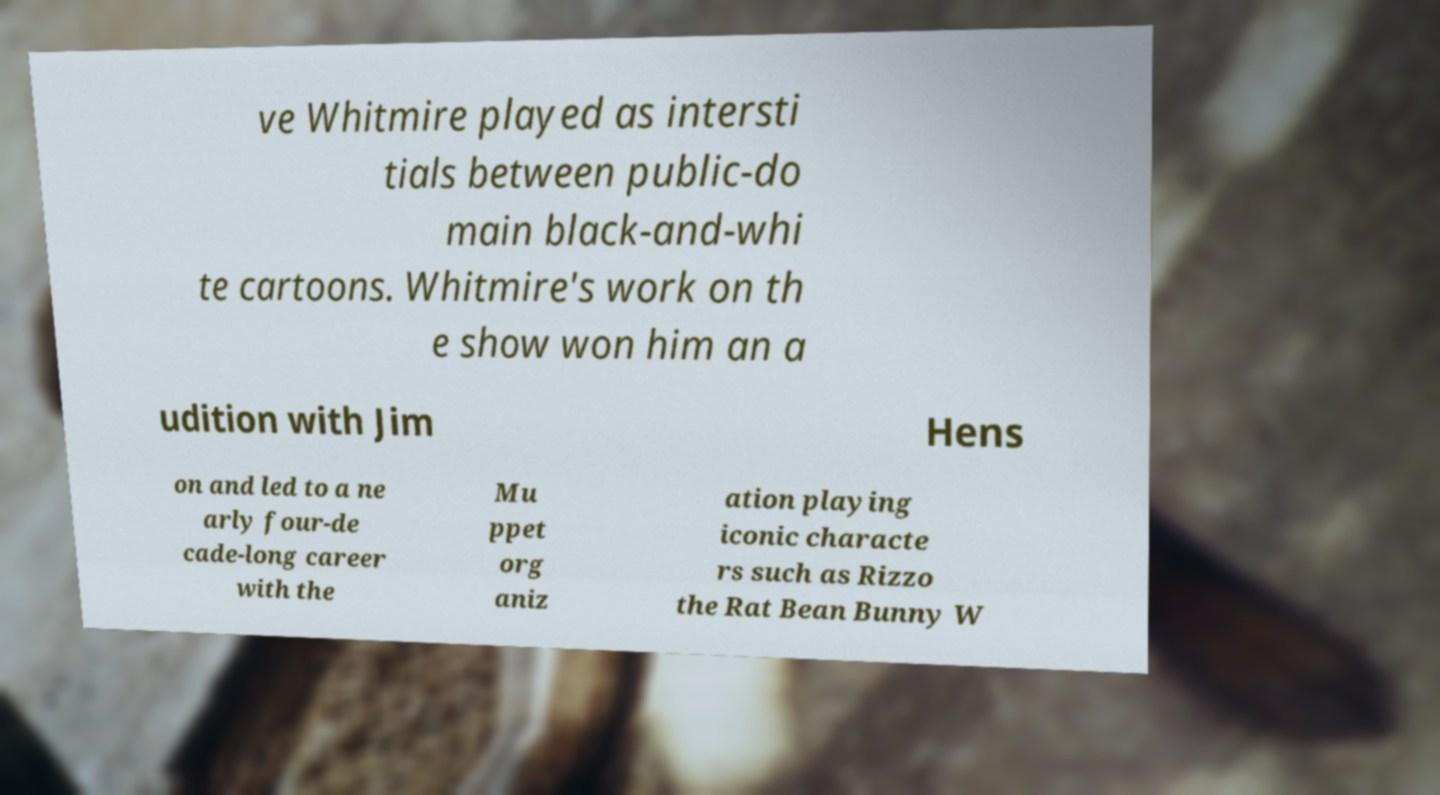Can you accurately transcribe the text from the provided image for me? ve Whitmire played as intersti tials between public-do main black-and-whi te cartoons. Whitmire's work on th e show won him an a udition with Jim Hens on and led to a ne arly four-de cade-long career with the Mu ppet org aniz ation playing iconic characte rs such as Rizzo the Rat Bean Bunny W 